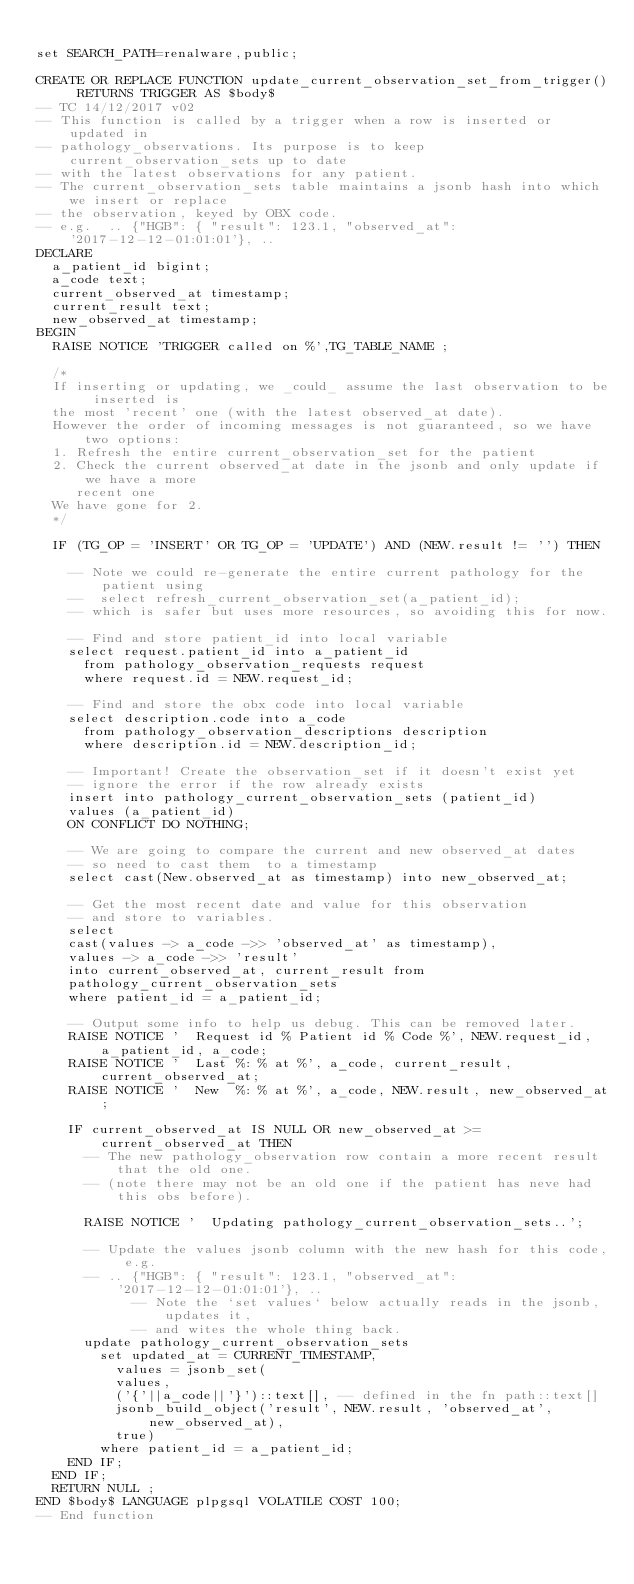<code> <loc_0><loc_0><loc_500><loc_500><_SQL_>
set SEARCH_PATH=renalware,public;

CREATE OR REPLACE FUNCTION update_current_observation_set_from_trigger() RETURNS TRIGGER AS $body$
-- TC 14/12/2017 v02
-- This function is called by a trigger when a row is inserted or updated in
-- pathology_observations. Its purpose is to keep current_observation_sets up to date
-- with the latest observations for any patient.
-- The current_observation_sets table maintains a jsonb hash into which we insert or replace
-- the observation, keyed by OBX code.
-- e.g.  .. {"HGB": { "result": 123.1, "observed_at": '2017-12-12-01:01:01'}, ..
DECLARE
  a_patient_id bigint;
  a_code text;
  current_observed_at timestamp;
  current_result text;
  new_observed_at timestamp;
BEGIN
  RAISE NOTICE 'TRIGGER called on %',TG_TABLE_NAME ;

  /*
  If inserting or updating, we _could_ assume the last observation to be inserted is
  the most 'recent' one (with the latest observed_at date).
  However the order of incoming messages is not guaranteed, so we have two options:
  1. Refresh the entire current_observation_set for the patient
  2. Check the current observed_at date in the jsonb and only update if we have a more
     recent one
  We have gone for 2.
  */

  IF (TG_OP = 'INSERT' OR TG_OP = 'UPDATE') AND (NEW.result != '') THEN

    -- Note we could re-generate the entire current pathology for the patient using
    --  select refresh_current_observation_set(a_patient_id);
    -- which is safer but uses more resources, so avoiding this for now.

    -- Find and store patient_id into local variable
    select request.patient_id into a_patient_id
      from pathology_observation_requests request
      where request.id = NEW.request_id;

    -- Find and store the obx code into local variable
    select description.code into a_code
      from pathology_observation_descriptions description
      where description.id = NEW.description_id;

    -- Important! Create the observation_set if it doesn't exist yet
    -- ignore the error if the row already exists
    insert into pathology_current_observation_sets (patient_id)
    values (a_patient_id)
    ON CONFLICT DO NOTHING;

    -- We are going to compare the current and new observed_at dates
    -- so need to cast them  to a timestamp
    select cast(New.observed_at as timestamp) into new_observed_at;

    -- Get the most recent date and value for this observation
    -- and store to variables.
    select
    cast(values -> a_code ->> 'observed_at' as timestamp),
    values -> a_code ->> 'result'
    into current_observed_at, current_result from
    pathology_current_observation_sets
    where patient_id = a_patient_id;

    -- Output some info to help us debug. This can be removed later.
    RAISE NOTICE '  Request id % Patient id % Code %', NEW.request_id, a_patient_id, a_code;
    RAISE NOTICE '  Last %: % at %', a_code, current_result, current_observed_at;
    RAISE NOTICE '  New  %: % at %', a_code, NEW.result, new_observed_at;

    IF current_observed_at IS NULL OR new_observed_at >= current_observed_at THEN
      -- The new pathology_observation row contain a more recent result that the old one.
      -- (note there may not be an old one if the patient has neve had this obs before).

      RAISE NOTICE '  Updating pathology_current_observation_sets..';

      -- Update the values jsonb column with the new hash for this code, e.g.
      -- .. {"HGB": { "result": 123.1, "observed_at": '2017-12-12-01:01:01'}, ..
            -- Note the `set values` below actually reads in the jsonb, updates it,
            -- and wites the whole thing back.
      update pathology_current_observation_sets
        set updated_at = CURRENT_TIMESTAMP,
          values = jsonb_set(
          values,
          ('{'||a_code||'}')::text[], -- defined in the fn path::text[]
          jsonb_build_object('result', NEW.result, 'observed_at', new_observed_at),
          true)
        where patient_id = a_patient_id;
    END IF;
  END IF;
  RETURN NULL ;
END $body$ LANGUAGE plpgsql VOLATILE COST 100;
-- End function
</code> 